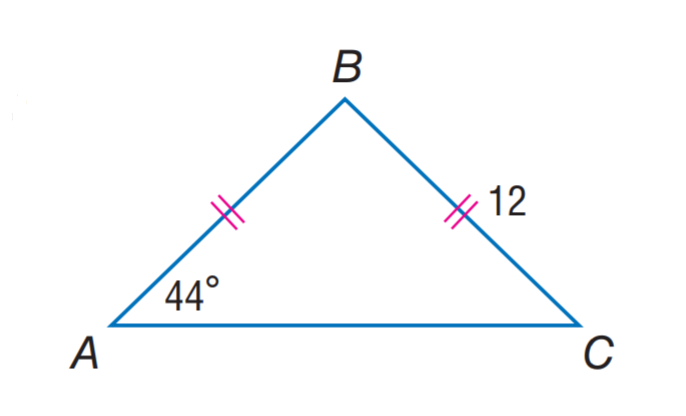Answer the mathemtical geometry problem and directly provide the correct option letter.
Question: Find A B.
Choices: A: 12 B: 16 C: 24 D: 44 A 